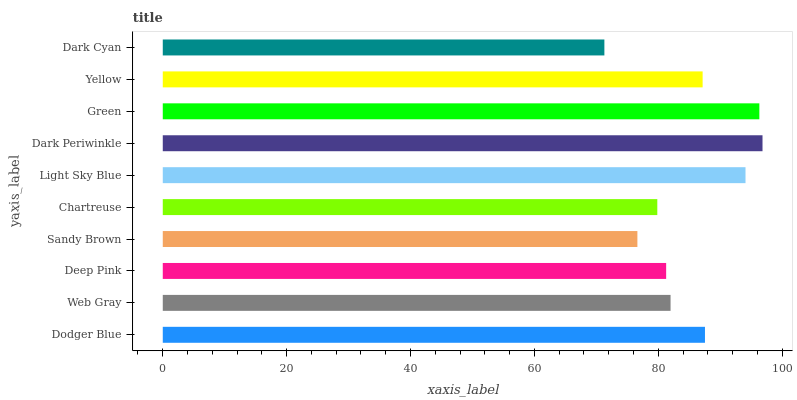Is Dark Cyan the minimum?
Answer yes or no. Yes. Is Dark Periwinkle the maximum?
Answer yes or no. Yes. Is Web Gray the minimum?
Answer yes or no. No. Is Web Gray the maximum?
Answer yes or no. No. Is Dodger Blue greater than Web Gray?
Answer yes or no. Yes. Is Web Gray less than Dodger Blue?
Answer yes or no. Yes. Is Web Gray greater than Dodger Blue?
Answer yes or no. No. Is Dodger Blue less than Web Gray?
Answer yes or no. No. Is Yellow the high median?
Answer yes or no. Yes. Is Web Gray the low median?
Answer yes or no. Yes. Is Sandy Brown the high median?
Answer yes or no. No. Is Green the low median?
Answer yes or no. No. 